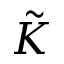<formula> <loc_0><loc_0><loc_500><loc_500>\tilde { K }</formula> 